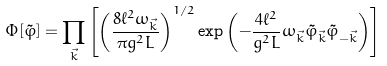Convert formula to latex. <formula><loc_0><loc_0><loc_500><loc_500>\Phi [ \tilde { \varphi } ] = \prod _ { \vec { k } } \left [ \left ( \frac { 8 \ell ^ { 2 } \omega _ { \vec { k } } } { \pi g ^ { 2 } L } \right ) ^ { 1 / 2 } \exp \left ( - \frac { 4 \ell ^ { 2 } } { g ^ { 2 } L } \omega _ { \vec { k } } \tilde { \varphi } _ { \vec { k } } \tilde { \varphi } _ { - \vec { k } } \right ) \right ]</formula> 